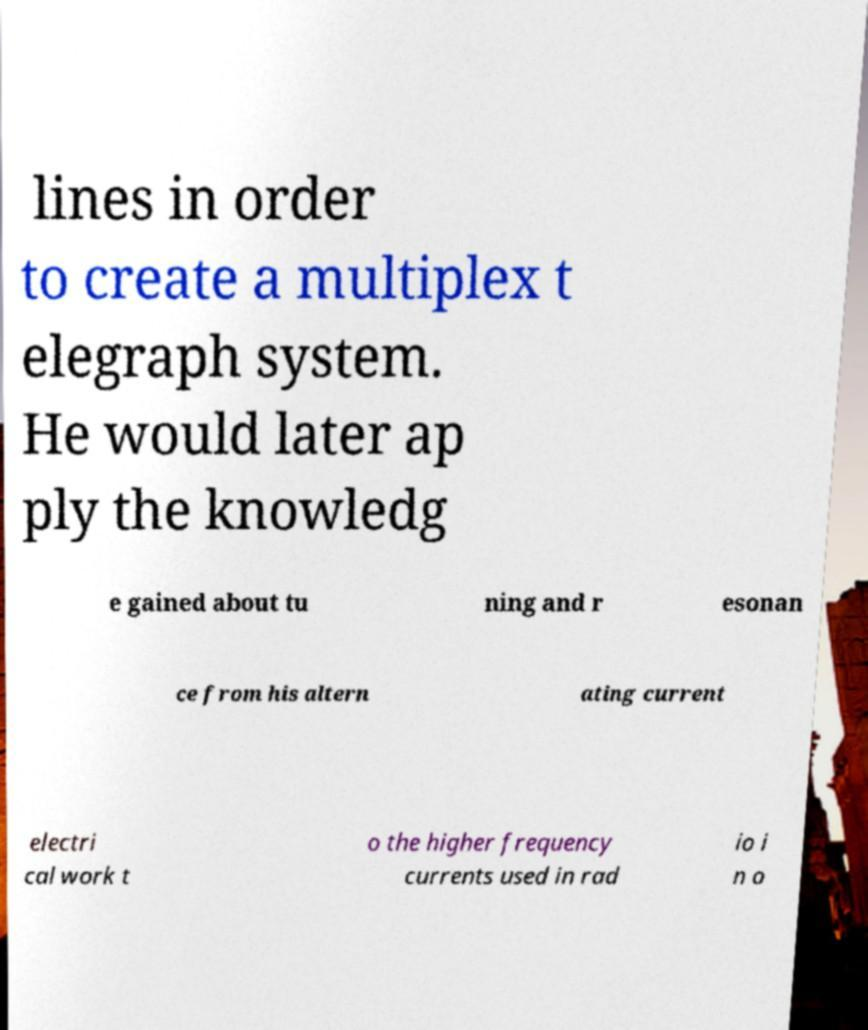Can you read and provide the text displayed in the image?This photo seems to have some interesting text. Can you extract and type it out for me? lines in order to create a multiplex t elegraph system. He would later ap ply the knowledg e gained about tu ning and r esonan ce from his altern ating current electri cal work t o the higher frequency currents used in rad io i n o 